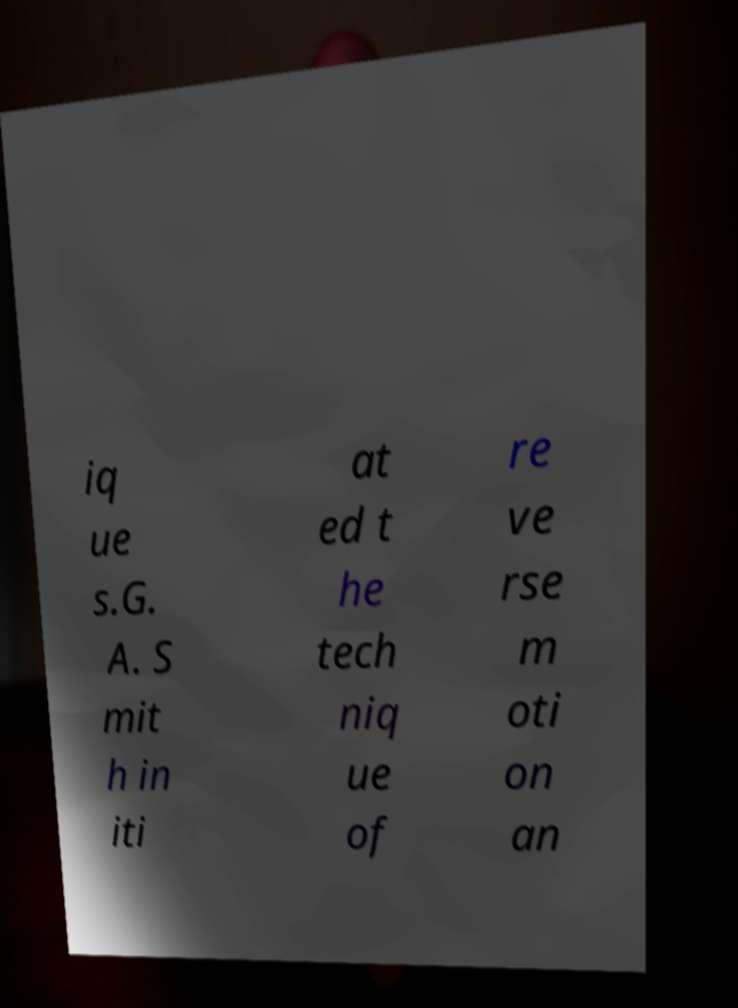Please read and relay the text visible in this image. What does it say? iq ue s.G. A. S mit h in iti at ed t he tech niq ue of re ve rse m oti on an 